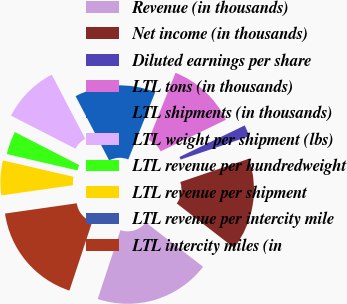<chart> <loc_0><loc_0><loc_500><loc_500><pie_chart><fcel>Revenue (in thousands)<fcel>Net income (in thousands)<fcel>Diluted earnings per share<fcel>LTL tons (in thousands)<fcel>LTL shipments (in thousands)<fcel>LTL weight per shipment (lbs)<fcel>LTL revenue per hundredweight<fcel>LTL revenue per shipment<fcel>LTL revenue per intercity mile<fcel>LTL intercity miles (in<nl><fcel>19.61%<fcel>15.69%<fcel>1.96%<fcel>11.76%<fcel>13.73%<fcel>9.8%<fcel>3.92%<fcel>5.88%<fcel>0.0%<fcel>17.65%<nl></chart> 